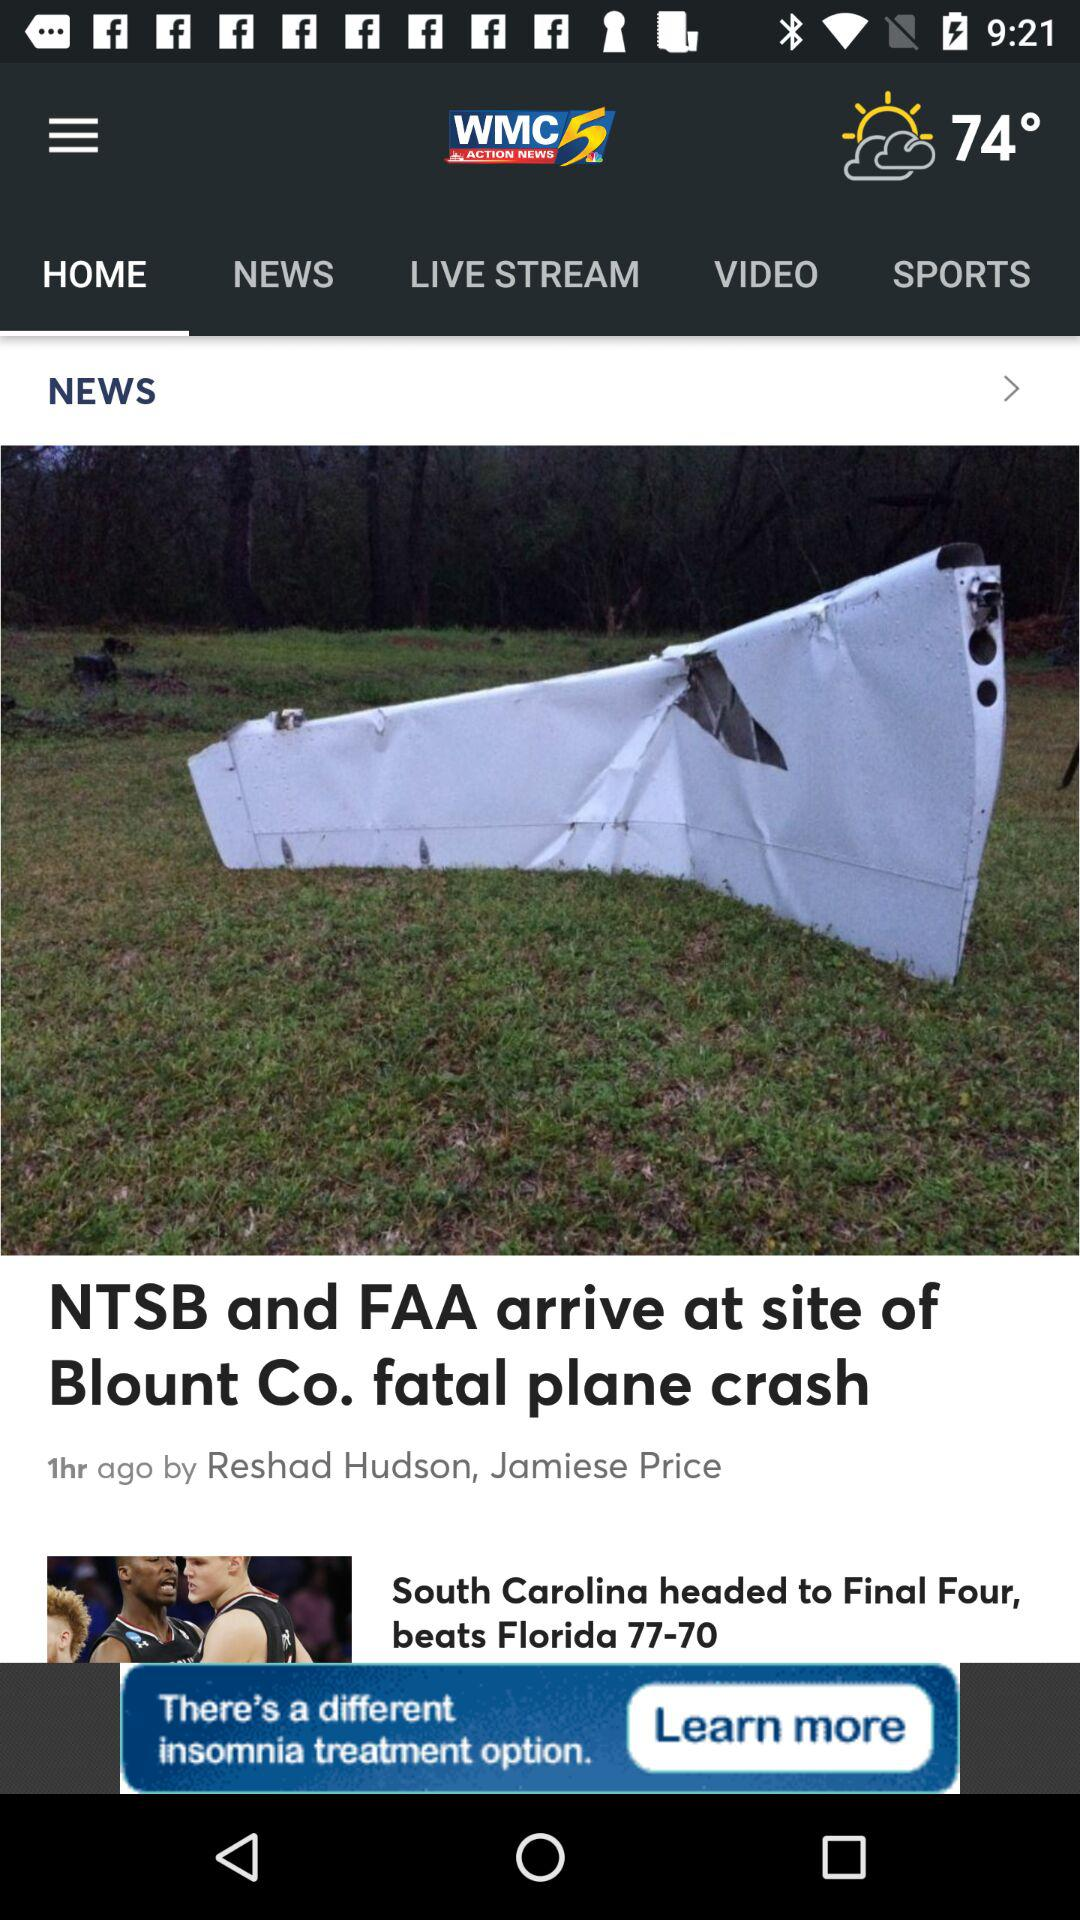How many hours ago was the news posted? The news was posted one hour ago. 